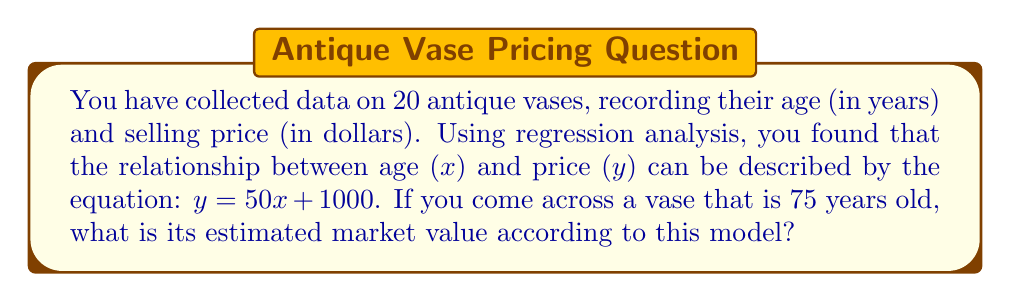Can you solve this math problem? To solve this problem, we'll follow these steps:

1. Identify the regression equation:
   The given equation is $y = 50x + 1000$, where:
   $y$ represents the estimated price in dollars
   $x$ represents the age of the vase in years
   
2. Identify the age of the vase in question:
   The vase is 75 years old, so $x = 75$

3. Substitute the age into the equation:
   $y = 50(75) + 1000$

4. Calculate the result:
   $y = 3750 + 1000$
   $y = 4750$

Therefore, according to this regression model, a 75-year-old vase is estimated to have a market value of $4,750.
Answer: $4,750 